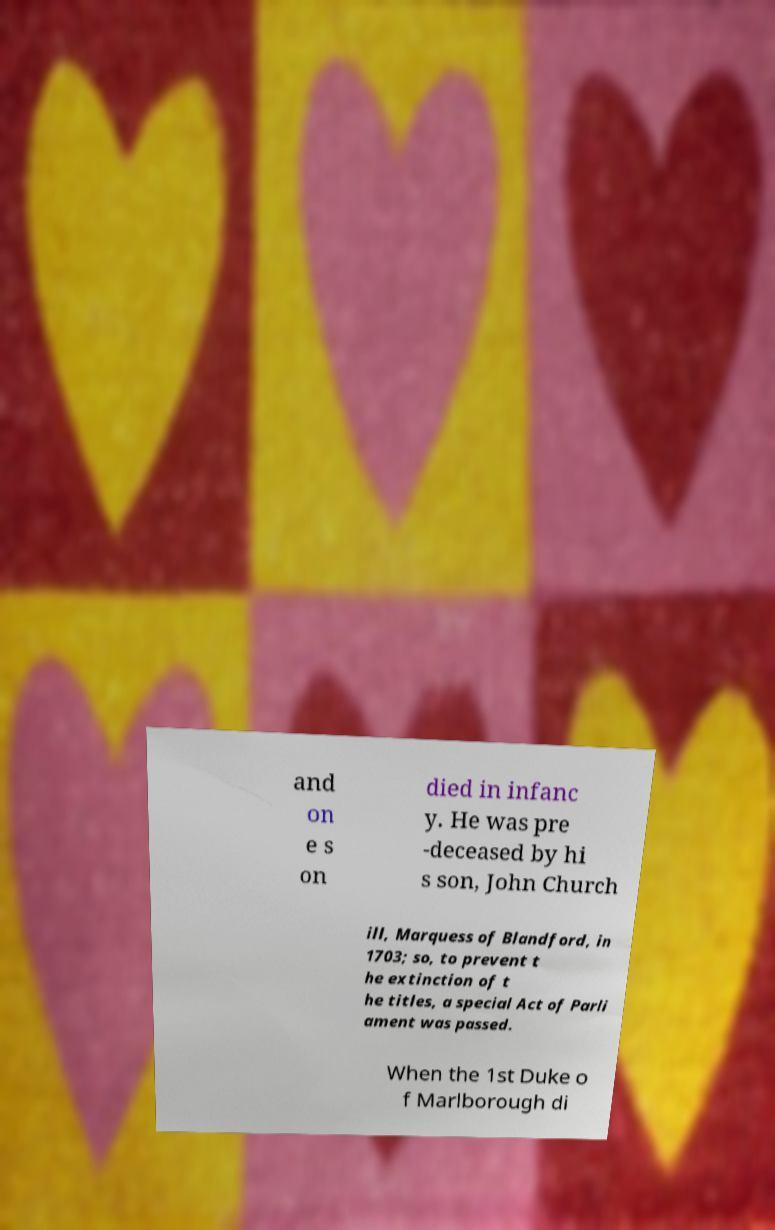Please read and relay the text visible in this image. What does it say? and on e s on died in infanc y. He was pre -deceased by hi s son, John Church ill, Marquess of Blandford, in 1703; so, to prevent t he extinction of t he titles, a special Act of Parli ament was passed. When the 1st Duke o f Marlborough di 